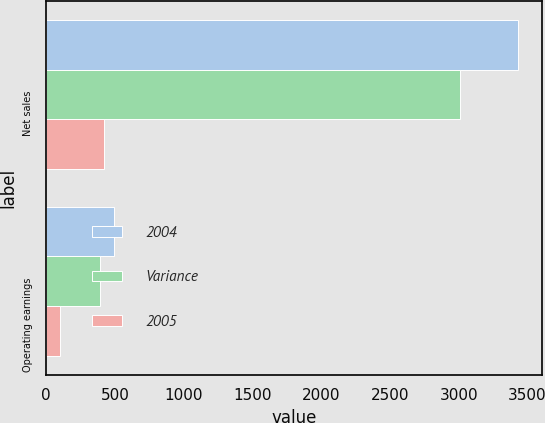Convert chart to OTSL. <chart><loc_0><loc_0><loc_500><loc_500><stacked_bar_chart><ecel><fcel>Net sales<fcel>Operating earnings<nl><fcel>2004<fcel>3433<fcel>495<nl><fcel>Variance<fcel>3012<fcel>393<nl><fcel>2005<fcel>421<fcel>102<nl></chart> 